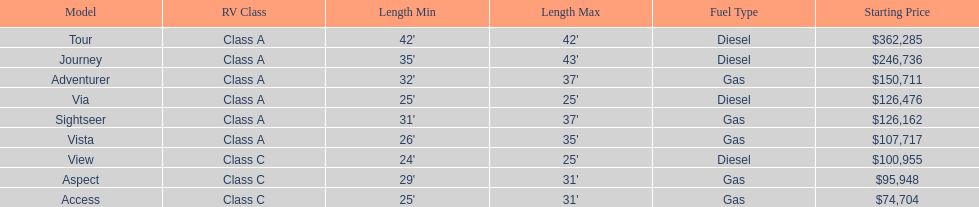Which model has the lowest started price? Access. 